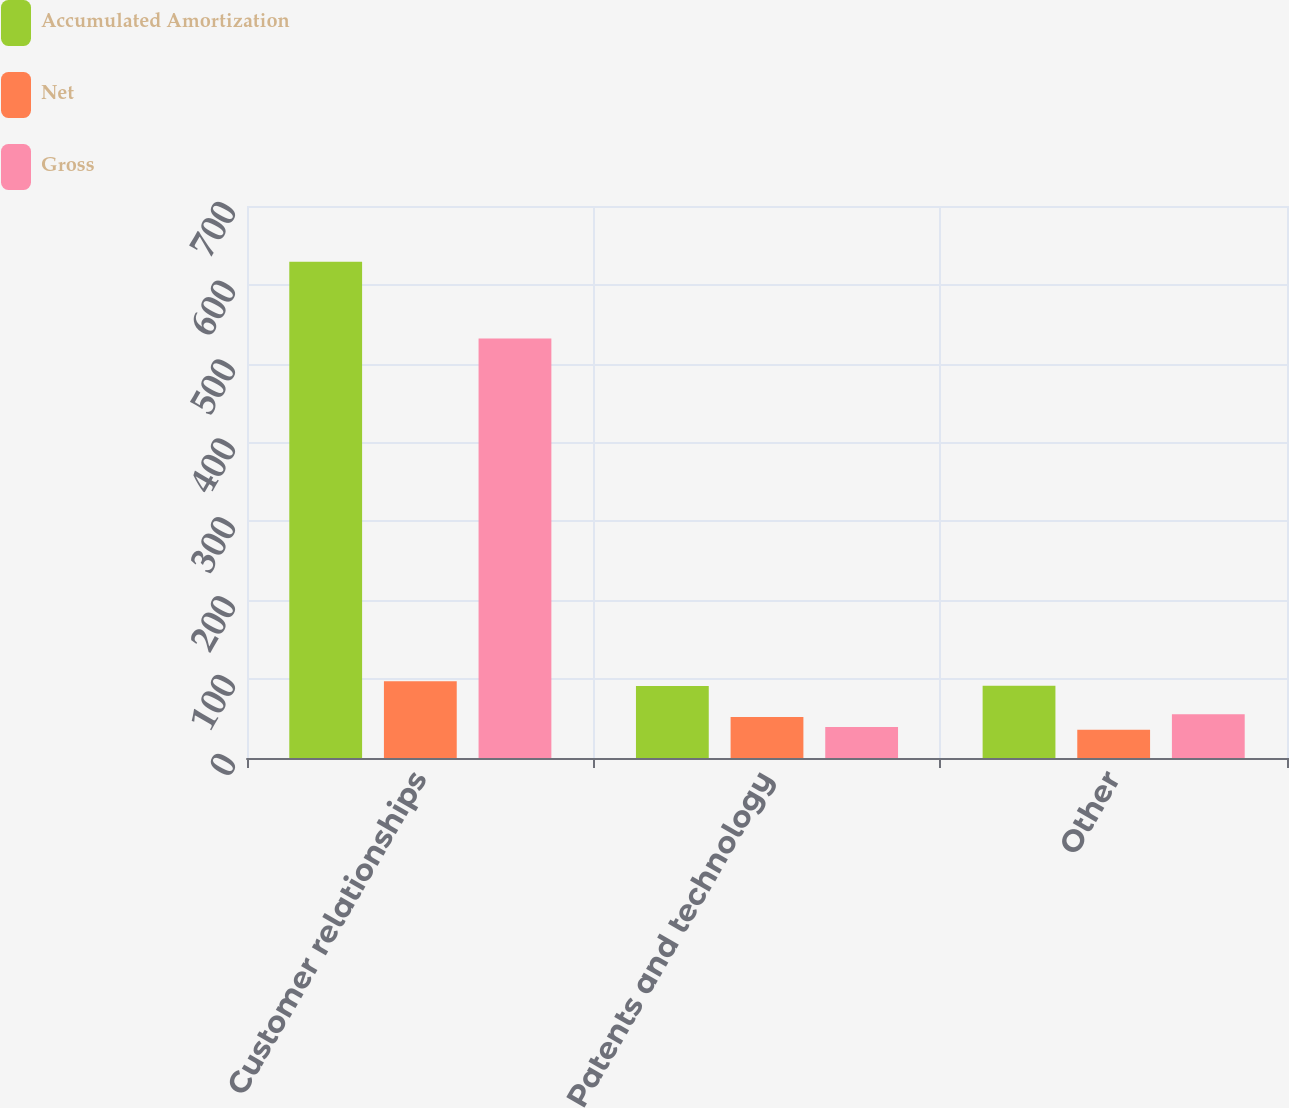Convert chart to OTSL. <chart><loc_0><loc_0><loc_500><loc_500><stacked_bar_chart><ecel><fcel>Customer relationships<fcel>Patents and technology<fcel>Other<nl><fcel>Accumulated Amortization<fcel>629.2<fcel>91.3<fcel>91.5<nl><fcel>Net<fcel>97.3<fcel>52.1<fcel>35.9<nl><fcel>Gross<fcel>531.9<fcel>39.2<fcel>55.6<nl></chart> 